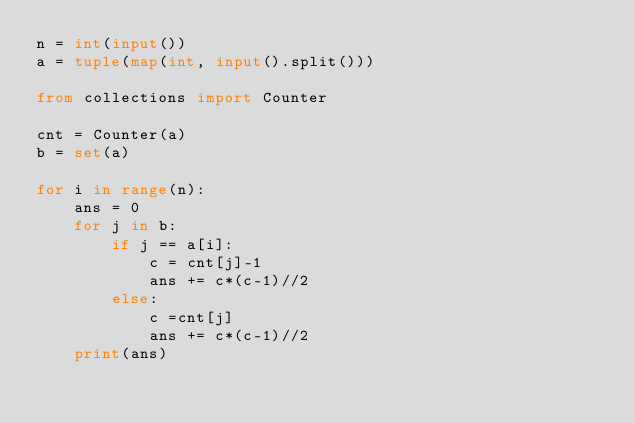Convert code to text. <code><loc_0><loc_0><loc_500><loc_500><_Python_>n = int(input())
a = tuple(map(int, input().split()))

from collections import Counter

cnt = Counter(a)
b = set(a)

for i in range(n):
    ans = 0
    for j in b:
        if j == a[i]:
            c = cnt[j]-1
            ans += c*(c-1)//2
        else:
            c =cnt[j]
            ans += c*(c-1)//2
    print(ans)
</code> 